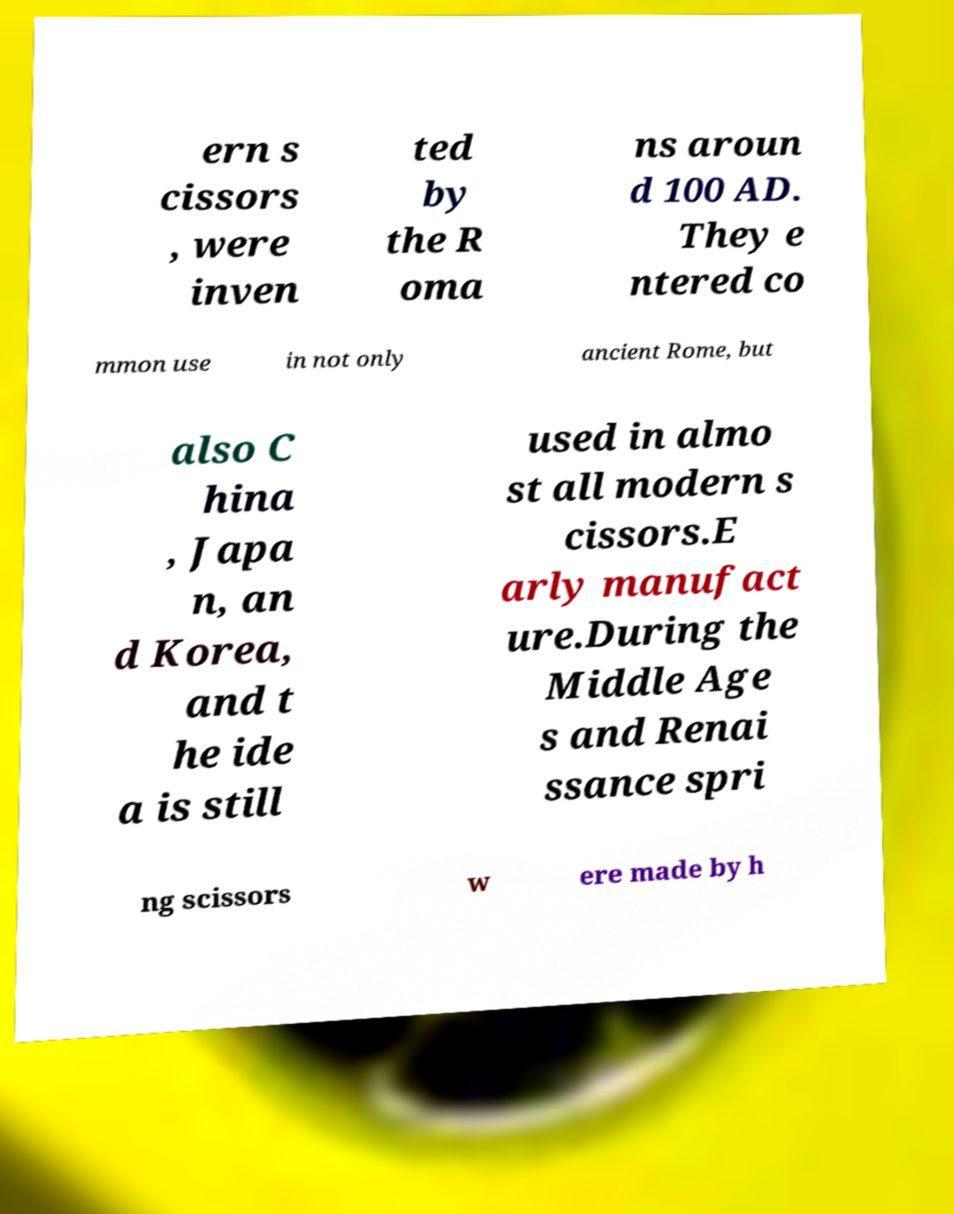Can you read and provide the text displayed in the image?This photo seems to have some interesting text. Can you extract and type it out for me? ern s cissors , were inven ted by the R oma ns aroun d 100 AD. They e ntered co mmon use in not only ancient Rome, but also C hina , Japa n, an d Korea, and t he ide a is still used in almo st all modern s cissors.E arly manufact ure.During the Middle Age s and Renai ssance spri ng scissors w ere made by h 